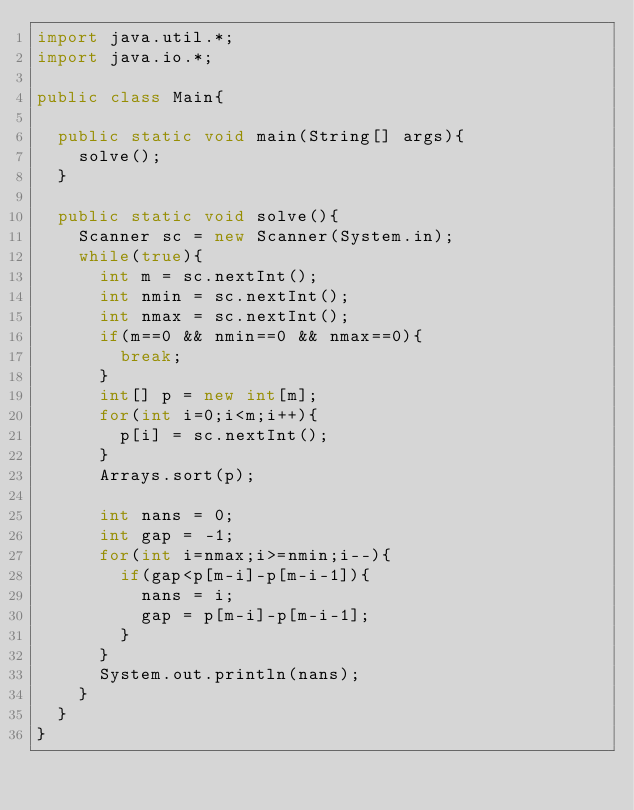Convert code to text. <code><loc_0><loc_0><loc_500><loc_500><_Java_>import java.util.*;
import java.io.*;

public class Main{

	public static void main(String[] args){
		solve();
	}

	public static void solve(){
		Scanner sc = new Scanner(System.in);
		while(true){
			int m = sc.nextInt();
			int nmin = sc.nextInt();
			int nmax = sc.nextInt();
			if(m==0 && nmin==0 && nmax==0){
				break;
			}
			int[] p = new int[m];
			for(int i=0;i<m;i++){
				p[i] = sc.nextInt();
			}
			Arrays.sort(p);
			
			int nans = 0;
			int gap = -1;
			for(int i=nmax;i>=nmin;i--){
				if(gap<p[m-i]-p[m-i-1]){
					nans = i;
					gap = p[m-i]-p[m-i-1];
				}
			}
			System.out.println(nans);
		}	
	}
}</code> 